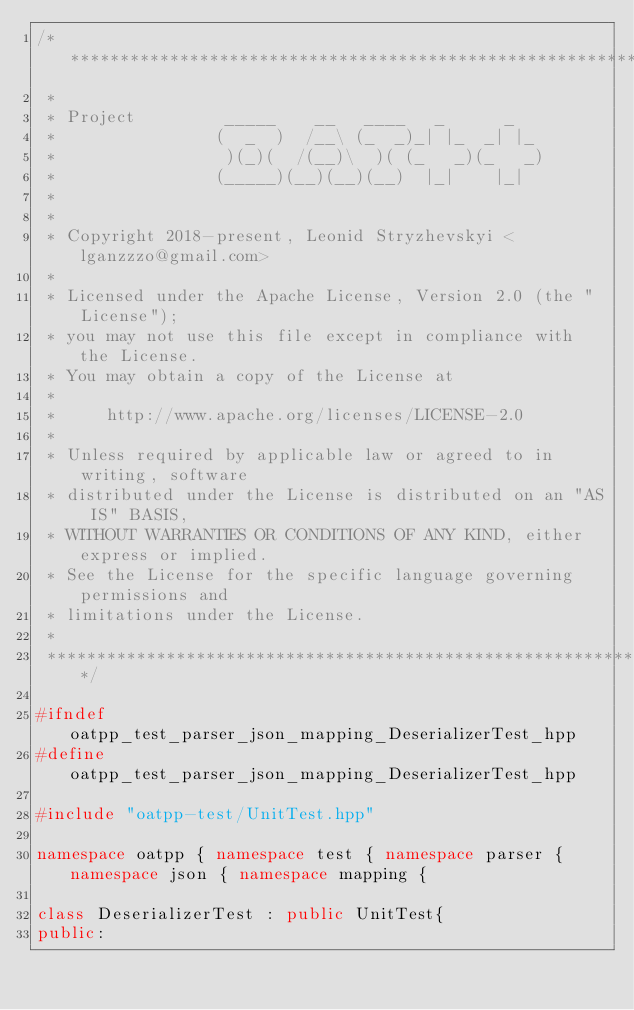<code> <loc_0><loc_0><loc_500><loc_500><_C++_>/***************************************************************************
 *
 * Project         _____    __   ____   _      _
 *                (  _  )  /__\ (_  _)_| |_  _| |_
 *                 )(_)(  /(__)\  )( (_   _)(_   _)
 *                (_____)(__)(__)(__)  |_|    |_|
 *
 *
 * Copyright 2018-present, Leonid Stryzhevskyi <lganzzzo@gmail.com>
 *
 * Licensed under the Apache License, Version 2.0 (the "License");
 * you may not use this file except in compliance with the License.
 * You may obtain a copy of the License at
 *
 *     http://www.apache.org/licenses/LICENSE-2.0
 *
 * Unless required by applicable law or agreed to in writing, software
 * distributed under the License is distributed on an "AS IS" BASIS,
 * WITHOUT WARRANTIES OR CONDITIONS OF ANY KIND, either express or implied.
 * See the License for the specific language governing permissions and
 * limitations under the License.
 *
 ***************************************************************************/

#ifndef oatpp_test_parser_json_mapping_DeserializerTest_hpp
#define oatpp_test_parser_json_mapping_DeserializerTest_hpp

#include "oatpp-test/UnitTest.hpp"

namespace oatpp { namespace test { namespace parser { namespace json { namespace mapping {
  
class DeserializerTest : public UnitTest{
public:
  </code> 